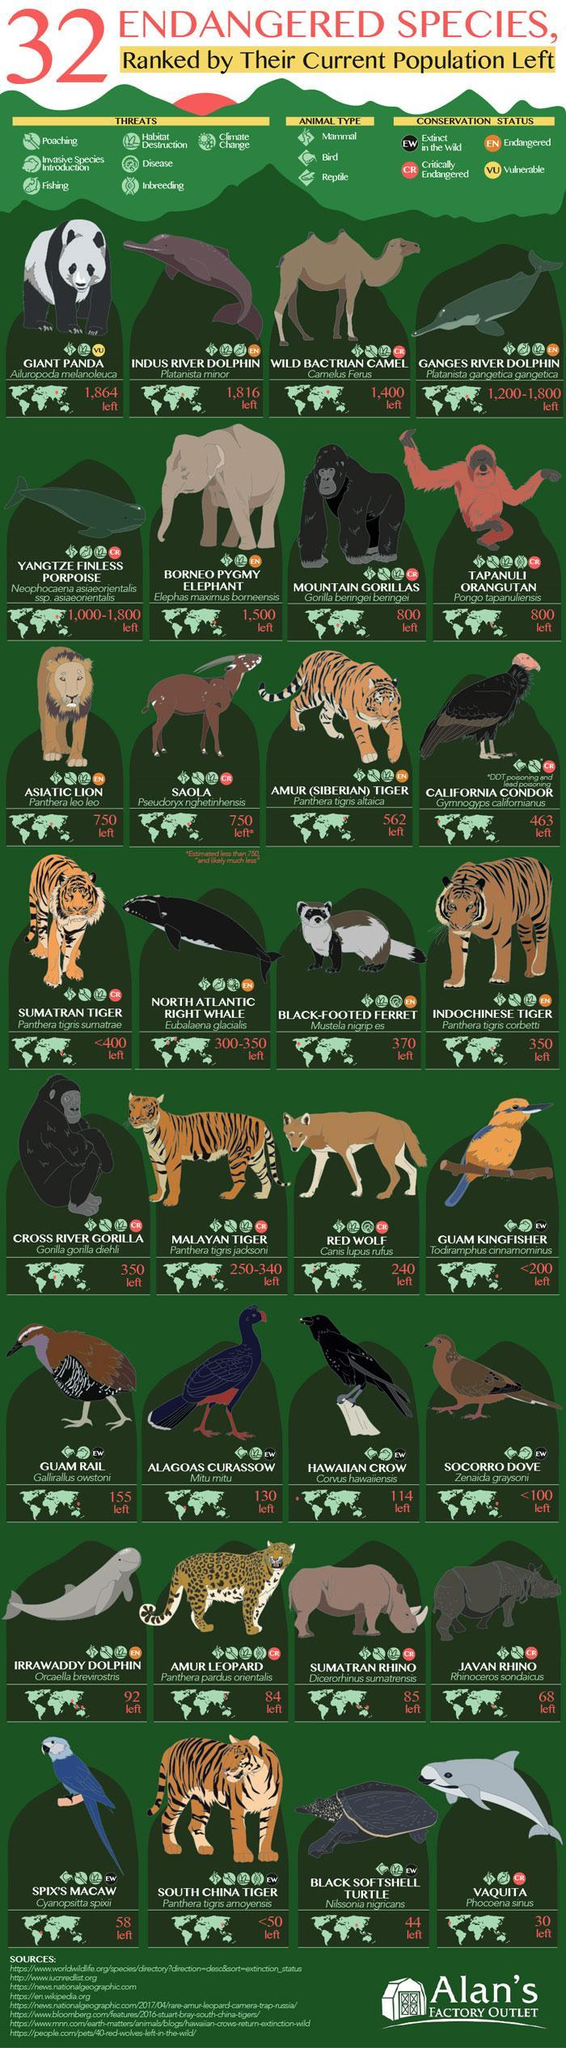How many threats mentioned in this infographic?
Answer the question with a short phrase. 7 How many animals have the rank of 800? 2 Which all are the animal types mentioned in this infographic? Mammal, Bird, Reptile How many animal types mentioned in this infographic? 3 How many animals have the rank of 750? 2 What is the number of conservation status mentioned in this infographic? 4 